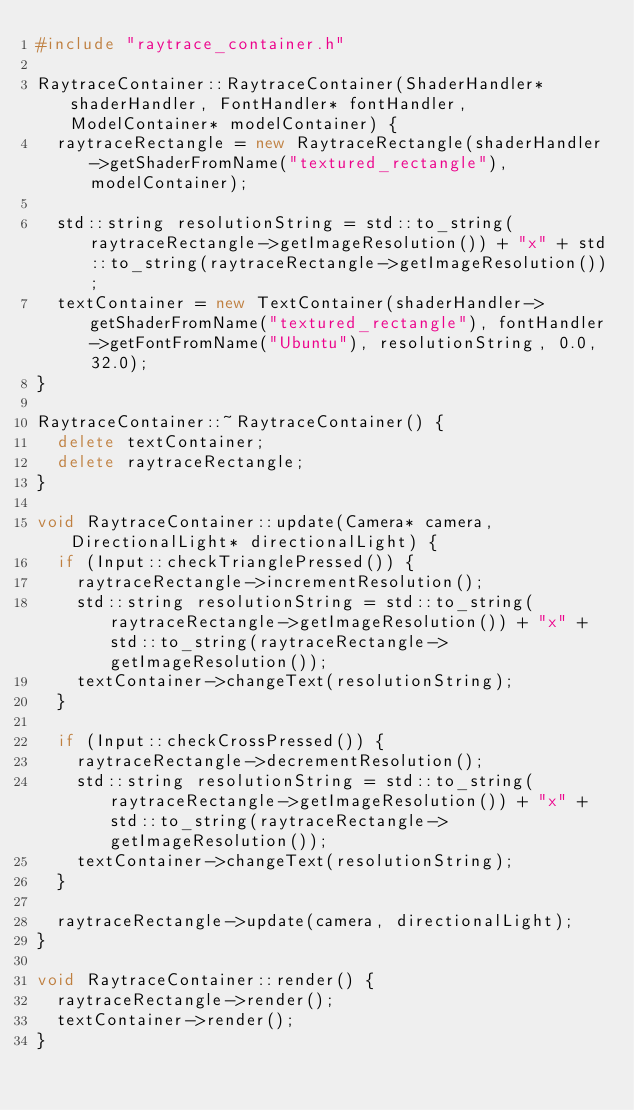<code> <loc_0><loc_0><loc_500><loc_500><_C++_>#include "raytrace_container.h"

RaytraceContainer::RaytraceContainer(ShaderHandler* shaderHandler, FontHandler* fontHandler, ModelContainer* modelContainer) {
  raytraceRectangle = new RaytraceRectangle(shaderHandler->getShaderFromName("textured_rectangle"), modelContainer);

  std::string resolutionString = std::to_string(raytraceRectangle->getImageResolution()) + "x" + std::to_string(raytraceRectangle->getImageResolution());
  textContainer = new TextContainer(shaderHandler->getShaderFromName("textured_rectangle"), fontHandler->getFontFromName("Ubuntu"), resolutionString, 0.0, 32.0);
}

RaytraceContainer::~RaytraceContainer() {
  delete textContainer;
  delete raytraceRectangle;
}

void RaytraceContainer::update(Camera* camera, DirectionalLight* directionalLight) {
  if (Input::checkTrianglePressed()) {
    raytraceRectangle->incrementResolution();
    std::string resolutionString = std::to_string(raytraceRectangle->getImageResolution()) + "x" + std::to_string(raytraceRectangle->getImageResolution());
    textContainer->changeText(resolutionString);
  }

  if (Input::checkCrossPressed()) {
    raytraceRectangle->decrementResolution();
    std::string resolutionString = std::to_string(raytraceRectangle->getImageResolution()) + "x" + std::to_string(raytraceRectangle->getImageResolution());
    textContainer->changeText(resolutionString);
  }

  raytraceRectangle->update(camera, directionalLight);
}

void RaytraceContainer::render() {
  raytraceRectangle->render();
  textContainer->render();
}</code> 